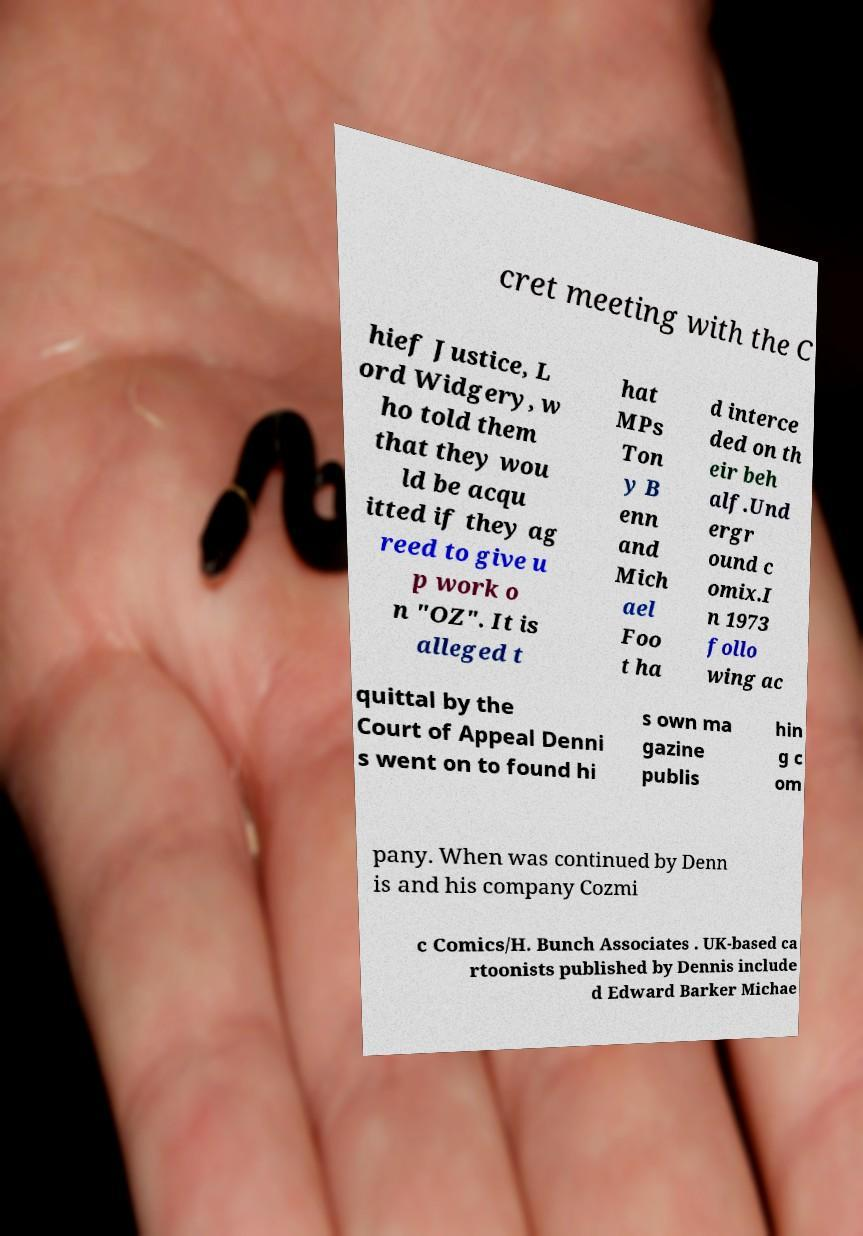Please identify and transcribe the text found in this image. cret meeting with the C hief Justice, L ord Widgery, w ho told them that they wou ld be acqu itted if they ag reed to give u p work o n "OZ". It is alleged t hat MPs Ton y B enn and Mich ael Foo t ha d interce ded on th eir beh alf.Und ergr ound c omix.I n 1973 follo wing ac quittal by the Court of Appeal Denni s went on to found hi s own ma gazine publis hin g c om pany. When was continued by Denn is and his company Cozmi c Comics/H. Bunch Associates . UK-based ca rtoonists published by Dennis include d Edward Barker Michae 